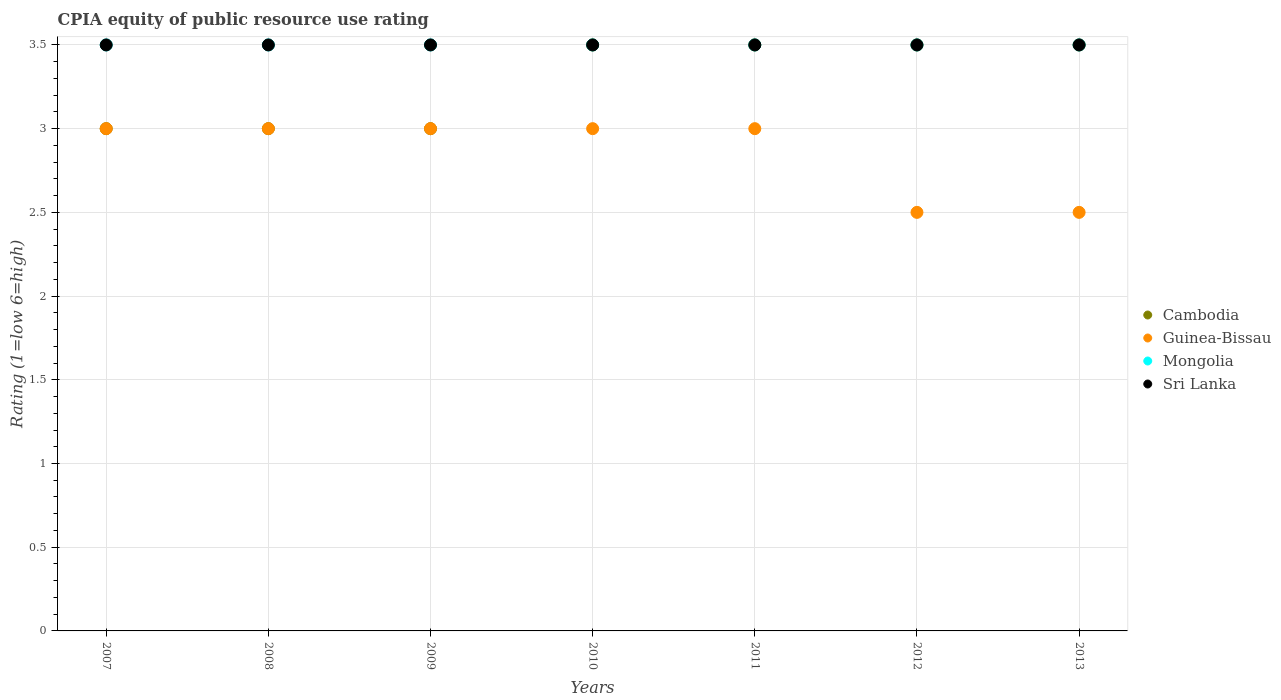How many different coloured dotlines are there?
Your answer should be very brief. 4. Across all years, what is the minimum CPIA rating in Cambodia?
Make the answer very short. 3. What is the total CPIA rating in Sri Lanka in the graph?
Offer a terse response. 24.5. What is the difference between the CPIA rating in Cambodia in 2010 and the CPIA rating in Sri Lanka in 2009?
Offer a terse response. 0. What is the average CPIA rating in Cambodia per year?
Keep it short and to the point. 3.29. Is the difference between the CPIA rating in Sri Lanka in 2007 and 2008 greater than the difference between the CPIA rating in Guinea-Bissau in 2007 and 2008?
Give a very brief answer. No. What is the difference between the highest and the second highest CPIA rating in Guinea-Bissau?
Provide a succinct answer. 0. Is the sum of the CPIA rating in Sri Lanka in 2010 and 2011 greater than the maximum CPIA rating in Mongolia across all years?
Your answer should be compact. Yes. Is it the case that in every year, the sum of the CPIA rating in Cambodia and CPIA rating in Mongolia  is greater than the sum of CPIA rating in Guinea-Bissau and CPIA rating in Sri Lanka?
Your answer should be compact. Yes. What is the difference between two consecutive major ticks on the Y-axis?
Ensure brevity in your answer.  0.5. Does the graph contain any zero values?
Provide a short and direct response. No. Where does the legend appear in the graph?
Your answer should be compact. Center right. How many legend labels are there?
Provide a succinct answer. 4. What is the title of the graph?
Keep it short and to the point. CPIA equity of public resource use rating. What is the label or title of the Y-axis?
Provide a succinct answer. Rating (1=low 6=high). What is the Rating (1=low 6=high) in Mongolia in 2007?
Offer a terse response. 3.5. What is the Rating (1=low 6=high) of Sri Lanka in 2007?
Ensure brevity in your answer.  3.5. What is the Rating (1=low 6=high) of Sri Lanka in 2008?
Your answer should be compact. 3.5. What is the Rating (1=low 6=high) of Cambodia in 2009?
Your answer should be very brief. 3. What is the Rating (1=low 6=high) of Mongolia in 2009?
Your response must be concise. 3.5. What is the Rating (1=low 6=high) in Guinea-Bissau in 2011?
Make the answer very short. 3. What is the Rating (1=low 6=high) in Mongolia in 2011?
Your response must be concise. 3.5. What is the Rating (1=low 6=high) in Sri Lanka in 2011?
Offer a terse response. 3.5. What is the Rating (1=low 6=high) in Cambodia in 2012?
Ensure brevity in your answer.  3.5. What is the Rating (1=low 6=high) of Mongolia in 2012?
Provide a short and direct response. 3.5. What is the Rating (1=low 6=high) of Cambodia in 2013?
Your answer should be very brief. 3.5. What is the Rating (1=low 6=high) in Guinea-Bissau in 2013?
Offer a very short reply. 2.5. What is the Rating (1=low 6=high) in Mongolia in 2013?
Provide a succinct answer. 3.5. Across all years, what is the maximum Rating (1=low 6=high) of Cambodia?
Make the answer very short. 3.5. Across all years, what is the maximum Rating (1=low 6=high) in Mongolia?
Offer a very short reply. 3.5. Across all years, what is the maximum Rating (1=low 6=high) of Sri Lanka?
Your answer should be very brief. 3.5. Across all years, what is the minimum Rating (1=low 6=high) of Cambodia?
Provide a short and direct response. 3. Across all years, what is the minimum Rating (1=low 6=high) in Mongolia?
Your answer should be compact. 3.5. Across all years, what is the minimum Rating (1=low 6=high) of Sri Lanka?
Your answer should be very brief. 3.5. What is the total Rating (1=low 6=high) of Cambodia in the graph?
Provide a short and direct response. 23. What is the total Rating (1=low 6=high) in Guinea-Bissau in the graph?
Provide a succinct answer. 20. What is the difference between the Rating (1=low 6=high) of Guinea-Bissau in 2007 and that in 2008?
Provide a succinct answer. 0. What is the difference between the Rating (1=low 6=high) in Cambodia in 2007 and that in 2009?
Offer a terse response. 0. What is the difference between the Rating (1=low 6=high) of Guinea-Bissau in 2007 and that in 2009?
Keep it short and to the point. 0. What is the difference between the Rating (1=low 6=high) of Mongolia in 2007 and that in 2009?
Give a very brief answer. 0. What is the difference between the Rating (1=low 6=high) of Sri Lanka in 2007 and that in 2009?
Offer a very short reply. 0. What is the difference between the Rating (1=low 6=high) of Mongolia in 2007 and that in 2010?
Offer a very short reply. 0. What is the difference between the Rating (1=low 6=high) in Cambodia in 2007 and that in 2011?
Offer a very short reply. -0.5. What is the difference between the Rating (1=low 6=high) of Sri Lanka in 2007 and that in 2011?
Provide a succinct answer. 0. What is the difference between the Rating (1=low 6=high) of Mongolia in 2007 and that in 2012?
Give a very brief answer. 0. What is the difference between the Rating (1=low 6=high) in Cambodia in 2007 and that in 2013?
Your answer should be compact. -0.5. What is the difference between the Rating (1=low 6=high) in Guinea-Bissau in 2007 and that in 2013?
Provide a short and direct response. 0.5. What is the difference between the Rating (1=low 6=high) of Sri Lanka in 2007 and that in 2013?
Your answer should be compact. 0. What is the difference between the Rating (1=low 6=high) in Cambodia in 2008 and that in 2009?
Provide a succinct answer. 0. What is the difference between the Rating (1=low 6=high) of Mongolia in 2008 and that in 2009?
Your response must be concise. 0. What is the difference between the Rating (1=low 6=high) in Sri Lanka in 2008 and that in 2009?
Make the answer very short. 0. What is the difference between the Rating (1=low 6=high) of Cambodia in 2008 and that in 2010?
Provide a succinct answer. -0.5. What is the difference between the Rating (1=low 6=high) of Guinea-Bissau in 2008 and that in 2010?
Offer a very short reply. 0. What is the difference between the Rating (1=low 6=high) in Guinea-Bissau in 2008 and that in 2011?
Your answer should be very brief. 0. What is the difference between the Rating (1=low 6=high) of Sri Lanka in 2008 and that in 2011?
Give a very brief answer. 0. What is the difference between the Rating (1=low 6=high) in Sri Lanka in 2008 and that in 2012?
Keep it short and to the point. 0. What is the difference between the Rating (1=low 6=high) in Cambodia in 2008 and that in 2013?
Your response must be concise. -0.5. What is the difference between the Rating (1=low 6=high) of Cambodia in 2009 and that in 2010?
Your answer should be compact. -0.5. What is the difference between the Rating (1=low 6=high) in Sri Lanka in 2009 and that in 2010?
Your answer should be very brief. 0. What is the difference between the Rating (1=low 6=high) of Cambodia in 2009 and that in 2011?
Offer a terse response. -0.5. What is the difference between the Rating (1=low 6=high) of Sri Lanka in 2009 and that in 2011?
Your response must be concise. 0. What is the difference between the Rating (1=low 6=high) in Cambodia in 2009 and that in 2012?
Make the answer very short. -0.5. What is the difference between the Rating (1=low 6=high) in Guinea-Bissau in 2009 and that in 2013?
Provide a short and direct response. 0.5. What is the difference between the Rating (1=low 6=high) of Guinea-Bissau in 2010 and that in 2011?
Make the answer very short. 0. What is the difference between the Rating (1=low 6=high) in Sri Lanka in 2010 and that in 2011?
Your answer should be compact. 0. What is the difference between the Rating (1=low 6=high) in Guinea-Bissau in 2010 and that in 2012?
Keep it short and to the point. 0.5. What is the difference between the Rating (1=low 6=high) of Cambodia in 2010 and that in 2013?
Offer a very short reply. 0. What is the difference between the Rating (1=low 6=high) in Sri Lanka in 2010 and that in 2013?
Offer a terse response. 0. What is the difference between the Rating (1=low 6=high) in Mongolia in 2011 and that in 2012?
Your response must be concise. 0. What is the difference between the Rating (1=low 6=high) in Cambodia in 2011 and that in 2013?
Ensure brevity in your answer.  0. What is the difference between the Rating (1=low 6=high) in Cambodia in 2012 and that in 2013?
Give a very brief answer. 0. What is the difference between the Rating (1=low 6=high) of Guinea-Bissau in 2012 and that in 2013?
Provide a short and direct response. 0. What is the difference between the Rating (1=low 6=high) of Mongolia in 2012 and that in 2013?
Offer a terse response. 0. What is the difference between the Rating (1=low 6=high) of Cambodia in 2007 and the Rating (1=low 6=high) of Mongolia in 2008?
Your answer should be compact. -0.5. What is the difference between the Rating (1=low 6=high) of Cambodia in 2007 and the Rating (1=low 6=high) of Sri Lanka in 2008?
Ensure brevity in your answer.  -0.5. What is the difference between the Rating (1=low 6=high) of Guinea-Bissau in 2007 and the Rating (1=low 6=high) of Mongolia in 2008?
Offer a terse response. -0.5. What is the difference between the Rating (1=low 6=high) of Mongolia in 2007 and the Rating (1=low 6=high) of Sri Lanka in 2008?
Provide a short and direct response. 0. What is the difference between the Rating (1=low 6=high) of Cambodia in 2007 and the Rating (1=low 6=high) of Guinea-Bissau in 2009?
Give a very brief answer. 0. What is the difference between the Rating (1=low 6=high) of Cambodia in 2007 and the Rating (1=low 6=high) of Mongolia in 2009?
Give a very brief answer. -0.5. What is the difference between the Rating (1=low 6=high) in Cambodia in 2007 and the Rating (1=low 6=high) in Sri Lanka in 2009?
Provide a short and direct response. -0.5. What is the difference between the Rating (1=low 6=high) of Guinea-Bissau in 2007 and the Rating (1=low 6=high) of Sri Lanka in 2009?
Ensure brevity in your answer.  -0.5. What is the difference between the Rating (1=low 6=high) in Mongolia in 2007 and the Rating (1=low 6=high) in Sri Lanka in 2009?
Ensure brevity in your answer.  0. What is the difference between the Rating (1=low 6=high) in Cambodia in 2007 and the Rating (1=low 6=high) in Mongolia in 2010?
Make the answer very short. -0.5. What is the difference between the Rating (1=low 6=high) in Cambodia in 2007 and the Rating (1=low 6=high) in Sri Lanka in 2010?
Give a very brief answer. -0.5. What is the difference between the Rating (1=low 6=high) of Cambodia in 2007 and the Rating (1=low 6=high) of Sri Lanka in 2011?
Ensure brevity in your answer.  -0.5. What is the difference between the Rating (1=low 6=high) in Guinea-Bissau in 2007 and the Rating (1=low 6=high) in Sri Lanka in 2011?
Provide a short and direct response. -0.5. What is the difference between the Rating (1=low 6=high) of Mongolia in 2007 and the Rating (1=low 6=high) of Sri Lanka in 2011?
Make the answer very short. 0. What is the difference between the Rating (1=low 6=high) of Cambodia in 2007 and the Rating (1=low 6=high) of Guinea-Bissau in 2012?
Provide a short and direct response. 0.5. What is the difference between the Rating (1=low 6=high) in Guinea-Bissau in 2007 and the Rating (1=low 6=high) in Sri Lanka in 2013?
Your answer should be compact. -0.5. What is the difference between the Rating (1=low 6=high) of Mongolia in 2007 and the Rating (1=low 6=high) of Sri Lanka in 2013?
Your response must be concise. 0. What is the difference between the Rating (1=low 6=high) of Cambodia in 2008 and the Rating (1=low 6=high) of Guinea-Bissau in 2009?
Offer a very short reply. 0. What is the difference between the Rating (1=low 6=high) in Cambodia in 2008 and the Rating (1=low 6=high) in Mongolia in 2009?
Your response must be concise. -0.5. What is the difference between the Rating (1=low 6=high) in Cambodia in 2008 and the Rating (1=low 6=high) in Sri Lanka in 2009?
Offer a very short reply. -0.5. What is the difference between the Rating (1=low 6=high) of Guinea-Bissau in 2008 and the Rating (1=low 6=high) of Mongolia in 2009?
Ensure brevity in your answer.  -0.5. What is the difference between the Rating (1=low 6=high) in Mongolia in 2008 and the Rating (1=low 6=high) in Sri Lanka in 2009?
Offer a very short reply. 0. What is the difference between the Rating (1=low 6=high) of Cambodia in 2008 and the Rating (1=low 6=high) of Sri Lanka in 2010?
Make the answer very short. -0.5. What is the difference between the Rating (1=low 6=high) of Guinea-Bissau in 2008 and the Rating (1=low 6=high) of Mongolia in 2010?
Make the answer very short. -0.5. What is the difference between the Rating (1=low 6=high) in Cambodia in 2008 and the Rating (1=low 6=high) in Guinea-Bissau in 2011?
Ensure brevity in your answer.  0. What is the difference between the Rating (1=low 6=high) in Cambodia in 2008 and the Rating (1=low 6=high) in Mongolia in 2011?
Ensure brevity in your answer.  -0.5. What is the difference between the Rating (1=low 6=high) in Guinea-Bissau in 2008 and the Rating (1=low 6=high) in Mongolia in 2011?
Your answer should be compact. -0.5. What is the difference between the Rating (1=low 6=high) in Guinea-Bissau in 2008 and the Rating (1=low 6=high) in Sri Lanka in 2011?
Your response must be concise. -0.5. What is the difference between the Rating (1=low 6=high) of Guinea-Bissau in 2008 and the Rating (1=low 6=high) of Sri Lanka in 2012?
Provide a short and direct response. -0.5. What is the difference between the Rating (1=low 6=high) in Mongolia in 2008 and the Rating (1=low 6=high) in Sri Lanka in 2012?
Offer a terse response. 0. What is the difference between the Rating (1=low 6=high) of Cambodia in 2008 and the Rating (1=low 6=high) of Sri Lanka in 2013?
Provide a succinct answer. -0.5. What is the difference between the Rating (1=low 6=high) of Guinea-Bissau in 2008 and the Rating (1=low 6=high) of Sri Lanka in 2013?
Keep it short and to the point. -0.5. What is the difference between the Rating (1=low 6=high) of Cambodia in 2009 and the Rating (1=low 6=high) of Guinea-Bissau in 2010?
Offer a terse response. 0. What is the difference between the Rating (1=low 6=high) in Cambodia in 2009 and the Rating (1=low 6=high) in Mongolia in 2010?
Provide a succinct answer. -0.5. What is the difference between the Rating (1=low 6=high) of Guinea-Bissau in 2009 and the Rating (1=low 6=high) of Mongolia in 2011?
Offer a very short reply. -0.5. What is the difference between the Rating (1=low 6=high) of Guinea-Bissau in 2009 and the Rating (1=low 6=high) of Sri Lanka in 2011?
Your answer should be compact. -0.5. What is the difference between the Rating (1=low 6=high) in Mongolia in 2009 and the Rating (1=low 6=high) in Sri Lanka in 2011?
Your answer should be very brief. 0. What is the difference between the Rating (1=low 6=high) of Cambodia in 2009 and the Rating (1=low 6=high) of Guinea-Bissau in 2012?
Provide a succinct answer. 0.5. What is the difference between the Rating (1=low 6=high) in Mongolia in 2009 and the Rating (1=low 6=high) in Sri Lanka in 2012?
Give a very brief answer. 0. What is the difference between the Rating (1=low 6=high) of Cambodia in 2009 and the Rating (1=low 6=high) of Guinea-Bissau in 2013?
Offer a terse response. 0.5. What is the difference between the Rating (1=low 6=high) in Mongolia in 2009 and the Rating (1=low 6=high) in Sri Lanka in 2013?
Offer a terse response. 0. What is the difference between the Rating (1=low 6=high) of Mongolia in 2010 and the Rating (1=low 6=high) of Sri Lanka in 2011?
Provide a short and direct response. 0. What is the difference between the Rating (1=low 6=high) in Cambodia in 2010 and the Rating (1=low 6=high) in Mongolia in 2012?
Provide a short and direct response. 0. What is the difference between the Rating (1=low 6=high) in Cambodia in 2010 and the Rating (1=low 6=high) in Sri Lanka in 2012?
Make the answer very short. 0. What is the difference between the Rating (1=low 6=high) in Cambodia in 2010 and the Rating (1=low 6=high) in Sri Lanka in 2013?
Your answer should be compact. 0. What is the difference between the Rating (1=low 6=high) of Guinea-Bissau in 2010 and the Rating (1=low 6=high) of Mongolia in 2013?
Provide a short and direct response. -0.5. What is the difference between the Rating (1=low 6=high) in Guinea-Bissau in 2010 and the Rating (1=low 6=high) in Sri Lanka in 2013?
Provide a short and direct response. -0.5. What is the difference between the Rating (1=low 6=high) in Cambodia in 2011 and the Rating (1=low 6=high) in Guinea-Bissau in 2012?
Make the answer very short. 1. What is the difference between the Rating (1=low 6=high) of Guinea-Bissau in 2011 and the Rating (1=low 6=high) of Mongolia in 2012?
Make the answer very short. -0.5. What is the difference between the Rating (1=low 6=high) of Mongolia in 2011 and the Rating (1=low 6=high) of Sri Lanka in 2012?
Offer a terse response. 0. What is the difference between the Rating (1=low 6=high) of Cambodia in 2011 and the Rating (1=low 6=high) of Sri Lanka in 2013?
Your answer should be compact. 0. What is the difference between the Rating (1=low 6=high) of Guinea-Bissau in 2011 and the Rating (1=low 6=high) of Mongolia in 2013?
Offer a terse response. -0.5. What is the difference between the Rating (1=low 6=high) in Guinea-Bissau in 2011 and the Rating (1=low 6=high) in Sri Lanka in 2013?
Offer a very short reply. -0.5. What is the difference between the Rating (1=low 6=high) in Mongolia in 2011 and the Rating (1=low 6=high) in Sri Lanka in 2013?
Offer a very short reply. 0. What is the difference between the Rating (1=low 6=high) of Guinea-Bissau in 2012 and the Rating (1=low 6=high) of Mongolia in 2013?
Provide a short and direct response. -1. What is the average Rating (1=low 6=high) of Cambodia per year?
Offer a very short reply. 3.29. What is the average Rating (1=low 6=high) of Guinea-Bissau per year?
Give a very brief answer. 2.86. What is the average Rating (1=low 6=high) of Mongolia per year?
Provide a succinct answer. 3.5. What is the average Rating (1=low 6=high) of Sri Lanka per year?
Your answer should be very brief. 3.5. In the year 2007, what is the difference between the Rating (1=low 6=high) in Cambodia and Rating (1=low 6=high) in Guinea-Bissau?
Your response must be concise. 0. In the year 2007, what is the difference between the Rating (1=low 6=high) of Cambodia and Rating (1=low 6=high) of Mongolia?
Make the answer very short. -0.5. In the year 2007, what is the difference between the Rating (1=low 6=high) of Cambodia and Rating (1=low 6=high) of Sri Lanka?
Your answer should be compact. -0.5. In the year 2007, what is the difference between the Rating (1=low 6=high) of Guinea-Bissau and Rating (1=low 6=high) of Mongolia?
Your response must be concise. -0.5. In the year 2007, what is the difference between the Rating (1=low 6=high) in Guinea-Bissau and Rating (1=low 6=high) in Sri Lanka?
Your answer should be compact. -0.5. In the year 2007, what is the difference between the Rating (1=low 6=high) in Mongolia and Rating (1=low 6=high) in Sri Lanka?
Your answer should be compact. 0. In the year 2008, what is the difference between the Rating (1=low 6=high) of Cambodia and Rating (1=low 6=high) of Guinea-Bissau?
Give a very brief answer. 0. In the year 2009, what is the difference between the Rating (1=low 6=high) in Cambodia and Rating (1=low 6=high) in Mongolia?
Keep it short and to the point. -0.5. In the year 2009, what is the difference between the Rating (1=low 6=high) of Cambodia and Rating (1=low 6=high) of Sri Lanka?
Ensure brevity in your answer.  -0.5. In the year 2009, what is the difference between the Rating (1=low 6=high) of Guinea-Bissau and Rating (1=low 6=high) of Mongolia?
Ensure brevity in your answer.  -0.5. In the year 2009, what is the difference between the Rating (1=low 6=high) in Guinea-Bissau and Rating (1=low 6=high) in Sri Lanka?
Give a very brief answer. -0.5. In the year 2009, what is the difference between the Rating (1=low 6=high) in Mongolia and Rating (1=low 6=high) in Sri Lanka?
Provide a succinct answer. 0. In the year 2010, what is the difference between the Rating (1=low 6=high) in Cambodia and Rating (1=low 6=high) in Guinea-Bissau?
Offer a very short reply. 0.5. In the year 2010, what is the difference between the Rating (1=low 6=high) in Cambodia and Rating (1=low 6=high) in Mongolia?
Keep it short and to the point. 0. In the year 2010, what is the difference between the Rating (1=low 6=high) in Cambodia and Rating (1=low 6=high) in Sri Lanka?
Provide a succinct answer. 0. In the year 2010, what is the difference between the Rating (1=low 6=high) in Guinea-Bissau and Rating (1=low 6=high) in Mongolia?
Your response must be concise. -0.5. In the year 2010, what is the difference between the Rating (1=low 6=high) in Guinea-Bissau and Rating (1=low 6=high) in Sri Lanka?
Offer a terse response. -0.5. In the year 2011, what is the difference between the Rating (1=low 6=high) in Guinea-Bissau and Rating (1=low 6=high) in Sri Lanka?
Make the answer very short. -0.5. In the year 2011, what is the difference between the Rating (1=low 6=high) in Mongolia and Rating (1=low 6=high) in Sri Lanka?
Your answer should be very brief. 0. In the year 2012, what is the difference between the Rating (1=low 6=high) of Cambodia and Rating (1=low 6=high) of Guinea-Bissau?
Your answer should be compact. 1. In the year 2012, what is the difference between the Rating (1=low 6=high) of Cambodia and Rating (1=low 6=high) of Mongolia?
Make the answer very short. 0. In the year 2013, what is the difference between the Rating (1=low 6=high) in Cambodia and Rating (1=low 6=high) in Guinea-Bissau?
Offer a very short reply. 1. In the year 2013, what is the difference between the Rating (1=low 6=high) in Mongolia and Rating (1=low 6=high) in Sri Lanka?
Offer a terse response. 0. What is the ratio of the Rating (1=low 6=high) of Guinea-Bissau in 2007 to that in 2008?
Ensure brevity in your answer.  1. What is the ratio of the Rating (1=low 6=high) in Cambodia in 2007 to that in 2009?
Ensure brevity in your answer.  1. What is the ratio of the Rating (1=low 6=high) of Guinea-Bissau in 2007 to that in 2010?
Make the answer very short. 1. What is the ratio of the Rating (1=low 6=high) of Mongolia in 2007 to that in 2010?
Your response must be concise. 1. What is the ratio of the Rating (1=low 6=high) of Cambodia in 2007 to that in 2011?
Your answer should be very brief. 0.86. What is the ratio of the Rating (1=low 6=high) in Guinea-Bissau in 2007 to that in 2011?
Provide a succinct answer. 1. What is the ratio of the Rating (1=low 6=high) of Sri Lanka in 2007 to that in 2012?
Your response must be concise. 1. What is the ratio of the Rating (1=low 6=high) of Cambodia in 2007 to that in 2013?
Offer a terse response. 0.86. What is the ratio of the Rating (1=low 6=high) in Guinea-Bissau in 2007 to that in 2013?
Make the answer very short. 1.2. What is the ratio of the Rating (1=low 6=high) of Mongolia in 2007 to that in 2013?
Offer a terse response. 1. What is the ratio of the Rating (1=low 6=high) of Sri Lanka in 2007 to that in 2013?
Provide a succinct answer. 1. What is the ratio of the Rating (1=low 6=high) in Guinea-Bissau in 2008 to that in 2009?
Keep it short and to the point. 1. What is the ratio of the Rating (1=low 6=high) of Mongolia in 2008 to that in 2009?
Ensure brevity in your answer.  1. What is the ratio of the Rating (1=low 6=high) of Sri Lanka in 2008 to that in 2009?
Provide a succinct answer. 1. What is the ratio of the Rating (1=low 6=high) of Guinea-Bissau in 2008 to that in 2010?
Make the answer very short. 1. What is the ratio of the Rating (1=low 6=high) in Sri Lanka in 2008 to that in 2010?
Give a very brief answer. 1. What is the ratio of the Rating (1=low 6=high) in Guinea-Bissau in 2008 to that in 2011?
Ensure brevity in your answer.  1. What is the ratio of the Rating (1=low 6=high) in Mongolia in 2008 to that in 2011?
Your answer should be compact. 1. What is the ratio of the Rating (1=low 6=high) in Cambodia in 2008 to that in 2012?
Keep it short and to the point. 0.86. What is the ratio of the Rating (1=low 6=high) of Guinea-Bissau in 2008 to that in 2012?
Offer a very short reply. 1.2. What is the ratio of the Rating (1=low 6=high) of Sri Lanka in 2008 to that in 2012?
Your response must be concise. 1. What is the ratio of the Rating (1=low 6=high) in Mongolia in 2008 to that in 2013?
Provide a succinct answer. 1. What is the ratio of the Rating (1=low 6=high) of Cambodia in 2009 to that in 2010?
Keep it short and to the point. 0.86. What is the ratio of the Rating (1=low 6=high) in Guinea-Bissau in 2009 to that in 2010?
Offer a very short reply. 1. What is the ratio of the Rating (1=low 6=high) in Mongolia in 2009 to that in 2010?
Make the answer very short. 1. What is the ratio of the Rating (1=low 6=high) in Guinea-Bissau in 2009 to that in 2011?
Ensure brevity in your answer.  1. What is the ratio of the Rating (1=low 6=high) of Mongolia in 2009 to that in 2011?
Keep it short and to the point. 1. What is the ratio of the Rating (1=low 6=high) of Sri Lanka in 2009 to that in 2011?
Provide a short and direct response. 1. What is the ratio of the Rating (1=low 6=high) of Cambodia in 2009 to that in 2012?
Keep it short and to the point. 0.86. What is the ratio of the Rating (1=low 6=high) in Cambodia in 2009 to that in 2013?
Offer a terse response. 0.86. What is the ratio of the Rating (1=low 6=high) in Guinea-Bissau in 2009 to that in 2013?
Offer a very short reply. 1.2. What is the ratio of the Rating (1=low 6=high) in Cambodia in 2010 to that in 2011?
Your response must be concise. 1. What is the ratio of the Rating (1=low 6=high) in Guinea-Bissau in 2010 to that in 2011?
Offer a terse response. 1. What is the ratio of the Rating (1=low 6=high) of Guinea-Bissau in 2010 to that in 2012?
Give a very brief answer. 1.2. What is the ratio of the Rating (1=low 6=high) in Sri Lanka in 2010 to that in 2012?
Ensure brevity in your answer.  1. What is the ratio of the Rating (1=low 6=high) in Cambodia in 2010 to that in 2013?
Give a very brief answer. 1. What is the ratio of the Rating (1=low 6=high) in Guinea-Bissau in 2010 to that in 2013?
Keep it short and to the point. 1.2. What is the ratio of the Rating (1=low 6=high) of Mongolia in 2010 to that in 2013?
Provide a short and direct response. 1. What is the ratio of the Rating (1=low 6=high) of Cambodia in 2011 to that in 2012?
Ensure brevity in your answer.  1. What is the ratio of the Rating (1=low 6=high) of Guinea-Bissau in 2011 to that in 2012?
Provide a short and direct response. 1.2. What is the ratio of the Rating (1=low 6=high) of Mongolia in 2011 to that in 2012?
Your answer should be very brief. 1. What is the ratio of the Rating (1=low 6=high) in Mongolia in 2011 to that in 2013?
Your answer should be very brief. 1. What is the ratio of the Rating (1=low 6=high) in Cambodia in 2012 to that in 2013?
Your response must be concise. 1. What is the ratio of the Rating (1=low 6=high) in Guinea-Bissau in 2012 to that in 2013?
Provide a succinct answer. 1. What is the difference between the highest and the second highest Rating (1=low 6=high) of Mongolia?
Offer a terse response. 0. What is the difference between the highest and the second highest Rating (1=low 6=high) in Sri Lanka?
Offer a terse response. 0. What is the difference between the highest and the lowest Rating (1=low 6=high) of Cambodia?
Provide a succinct answer. 0.5. What is the difference between the highest and the lowest Rating (1=low 6=high) of Guinea-Bissau?
Your answer should be compact. 0.5. What is the difference between the highest and the lowest Rating (1=low 6=high) of Mongolia?
Your answer should be very brief. 0. 